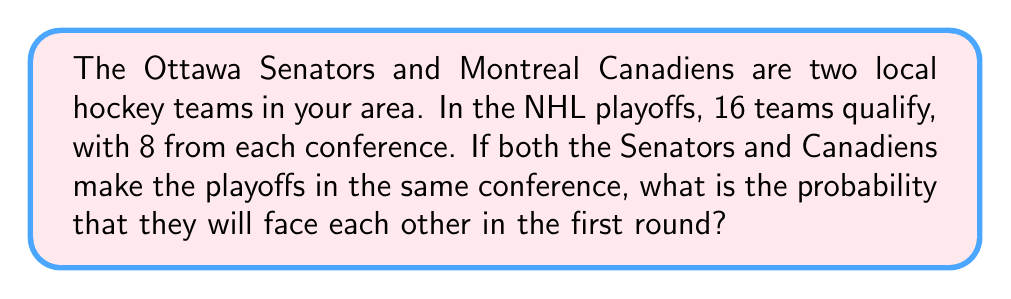Help me with this question. Let's approach this step-by-step:

1) In each conference, 8 teams qualify for the playoffs.

2) The playoff matchups in the first round are determined by seeding:
   1st vs 8th, 2nd vs 7th, 3rd vs 6th, and 4th vs 5th.

3) For the Senators and Canadiens to face each other, they need to be in one of these pairs.

4) There are 4 possible ways this can happen:
   - Senators 1st, Canadiens 8th (or vice versa)
   - Senators 2nd, Canadiens 7th (or vice versa)
   - Senators 3rd, Canadiens 6th (or vice versa)
   - Senators 4th, Canadiens 5th (or vice versa)

5) To calculate the probability, we need to determine:
   a) Total number of ways to arrange 8 teams
   b) Number of favorable arrangements

6) Total arrangements: This is a permutation of 8 teams, which is 8! = 40,320

7) Favorable arrangements: For each of the 4 possible matchups, we have:
   - 2 ways to arrange Senators and Canadiens
   - 6! ways to arrange the other 6 teams
   So, favorable arrangements = 4 * 2 * 6! = 5,760

8) Probability = Favorable outcomes / Total outcomes
   $$ P = \frac{4 * 2 * 6!}{8!} = \frac{5,760}{40,320} = \frac{1}{7} $$
Answer: $\frac{1}{7}$ 